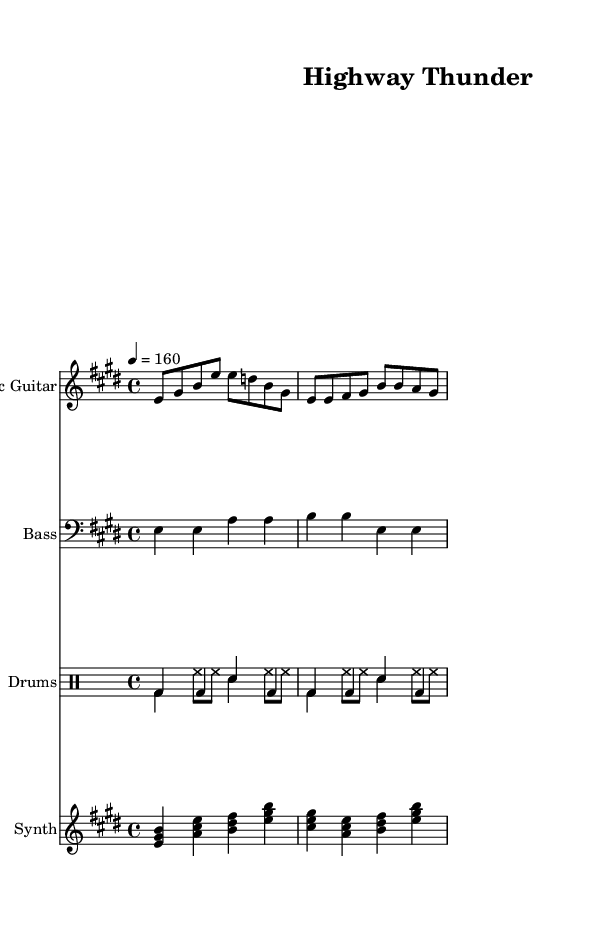What is the key signature of this music? The key signature shown in the music indicates that the piece is in E major, which includes four sharps. The key is identified at the beginning of the staff.
Answer: E major What is the time signature of this piece? The time signature is notated at the beginning of the music, and it shows that the piece is in 4/4 time, meaning there are four beats per measure.
Answer: 4/4 What is the tempo marking? The tempo marking indicates the speed of the piece. The marking “4 = 160” means there are 160 beats per minute, suggesting a fast-paced song. This can be found at the top of the score.
Answer: 160 How many measures does the electric guitar part contain in the excerpt? By scanning the electric guitar part notation, we can count the number of measures. The notation shows 4 measures beneath the staff.
Answer: 4 Which instruments are featured in the score? The score lists multiple instruments. By reading the instrument names before each staff, we can identify them as Electric Guitar, Bass, Drums, and Synth.
Answer: Electric Guitar, Bass, Drums, Synth What kind of feel does the "drums style" section bring to the music? The "drums style" section in this sheet music indicates a rhythmic and driving feel. The specific notation includes a mix of bass drum and snare hits combined with hi-hat patterns, which are characteristic of upbeat rock music.
Answer: Upbeat rock 